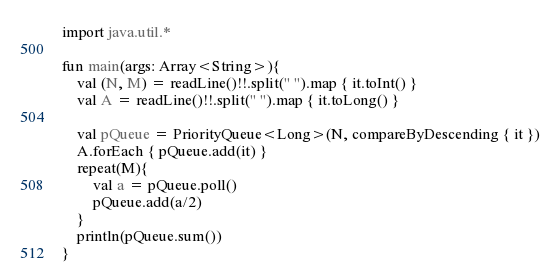Convert code to text. <code><loc_0><loc_0><loc_500><loc_500><_Kotlin_>import java.util.*

fun main(args: Array<String>){
    val (N, M) = readLine()!!.split(" ").map { it.toInt() }
    val A = readLine()!!.split(" ").map { it.toLong() }

    val pQueue = PriorityQueue<Long>(N, compareByDescending { it })
    A.forEach { pQueue.add(it) }
    repeat(M){
        val a = pQueue.poll()
        pQueue.add(a/2)
    }
    println(pQueue.sum())
}</code> 